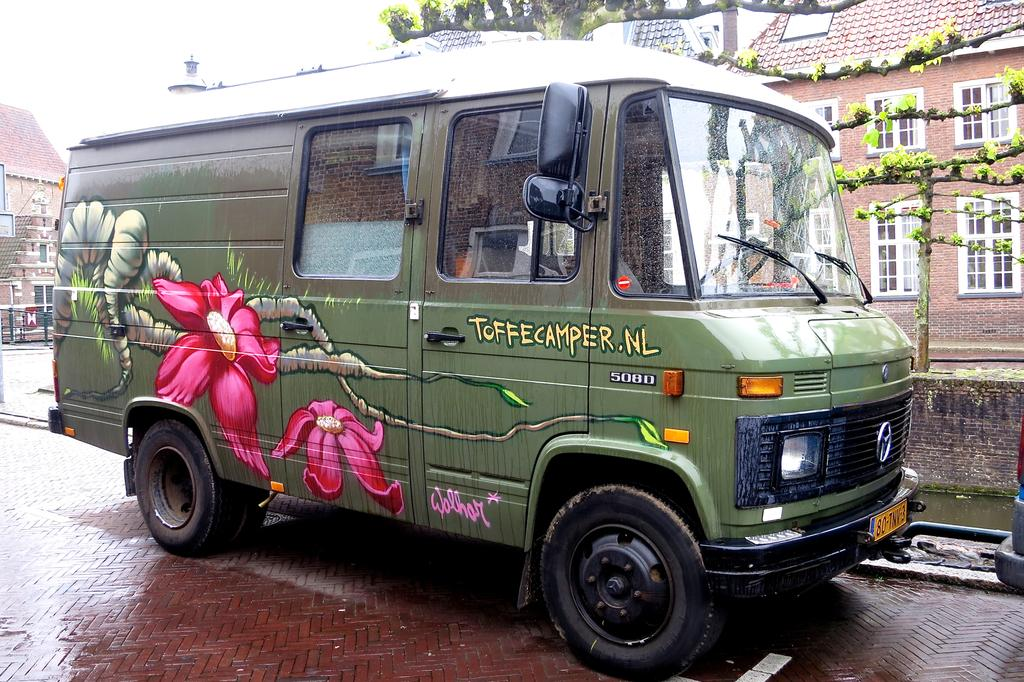<image>
Render a clear and concise summary of the photo. A green van with flowers painted on it that says Toffecamper.nl. 